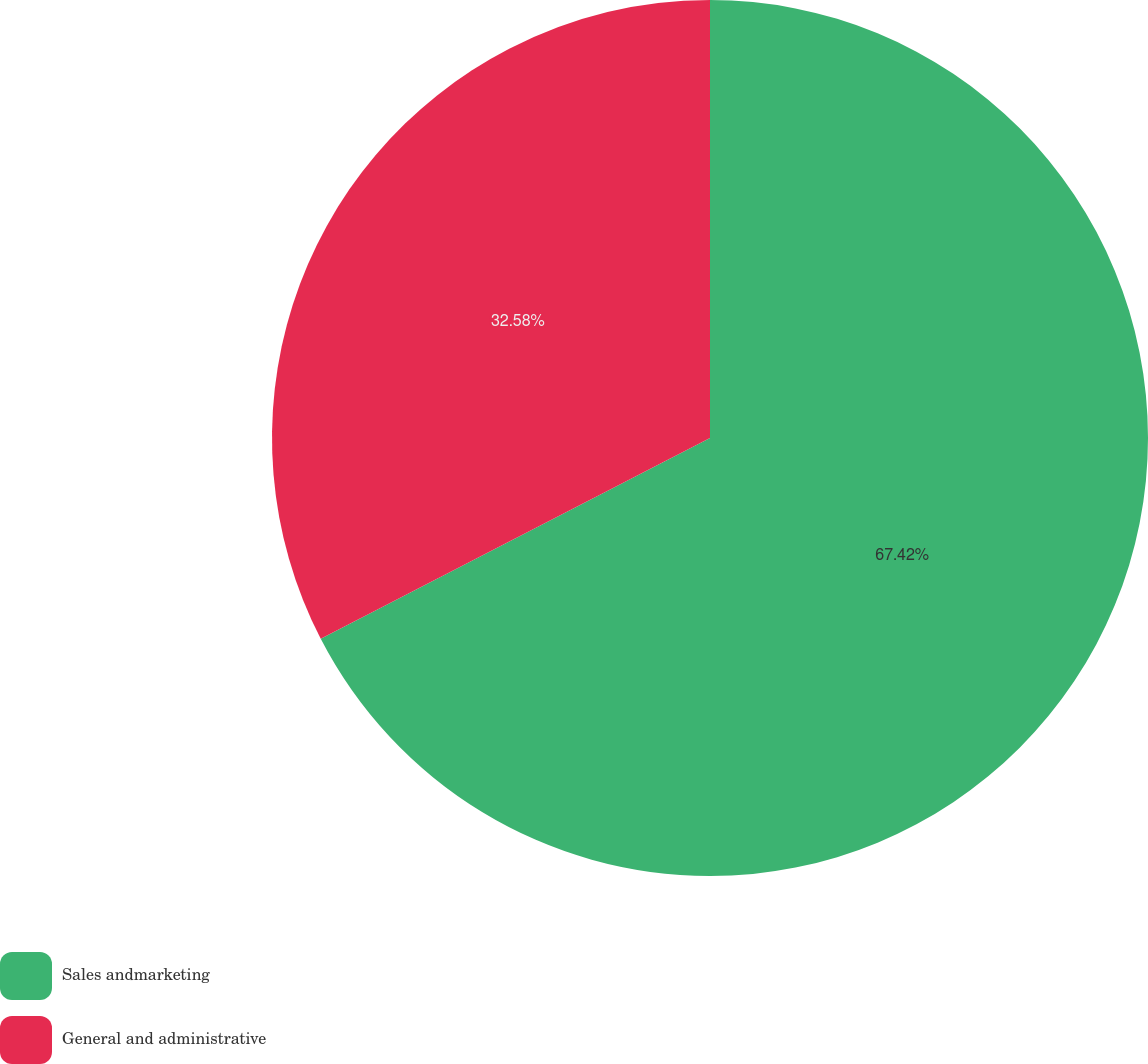Convert chart to OTSL. <chart><loc_0><loc_0><loc_500><loc_500><pie_chart><fcel>Sales andmarketing<fcel>General and administrative<nl><fcel>67.42%<fcel>32.58%<nl></chart> 